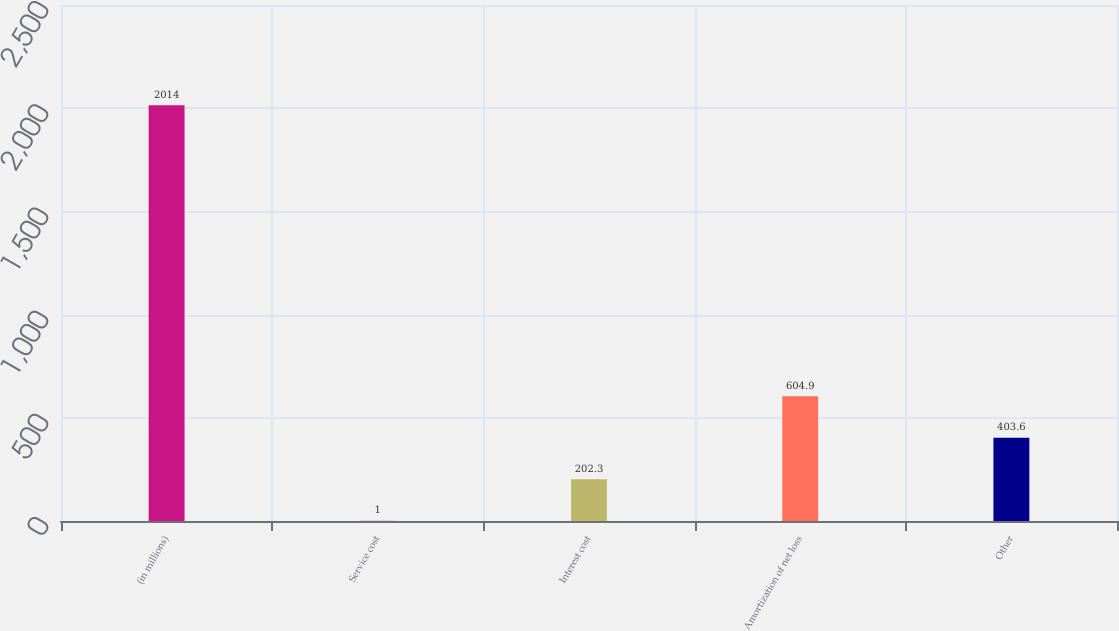<chart> <loc_0><loc_0><loc_500><loc_500><bar_chart><fcel>(in millions)<fcel>Service cost<fcel>Interest cost<fcel>Amortization of net loss<fcel>Other<nl><fcel>2014<fcel>1<fcel>202.3<fcel>604.9<fcel>403.6<nl></chart> 